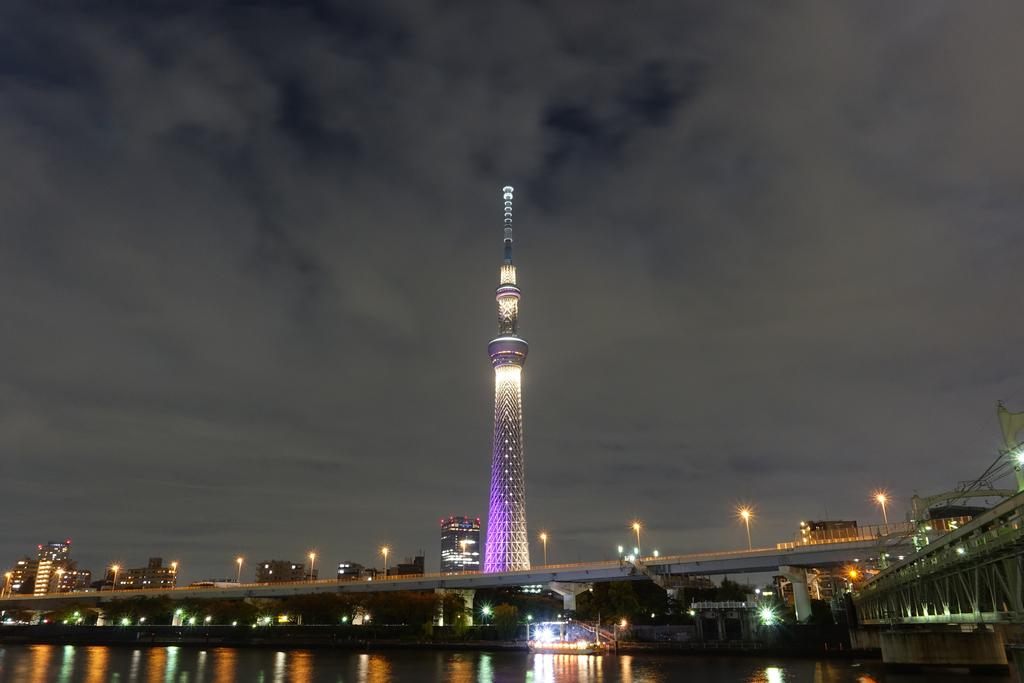What is the main structure in the image? There is a tower in the image. How is the tower positioned in relation to other structures? The tower is situated between buildings. What natural feature is visible in front of the tower? There is a lake in front of the tower. How does the beginner learn to use the thing in the image? There is no "thing" present in the image, and no learning process is depicted. 